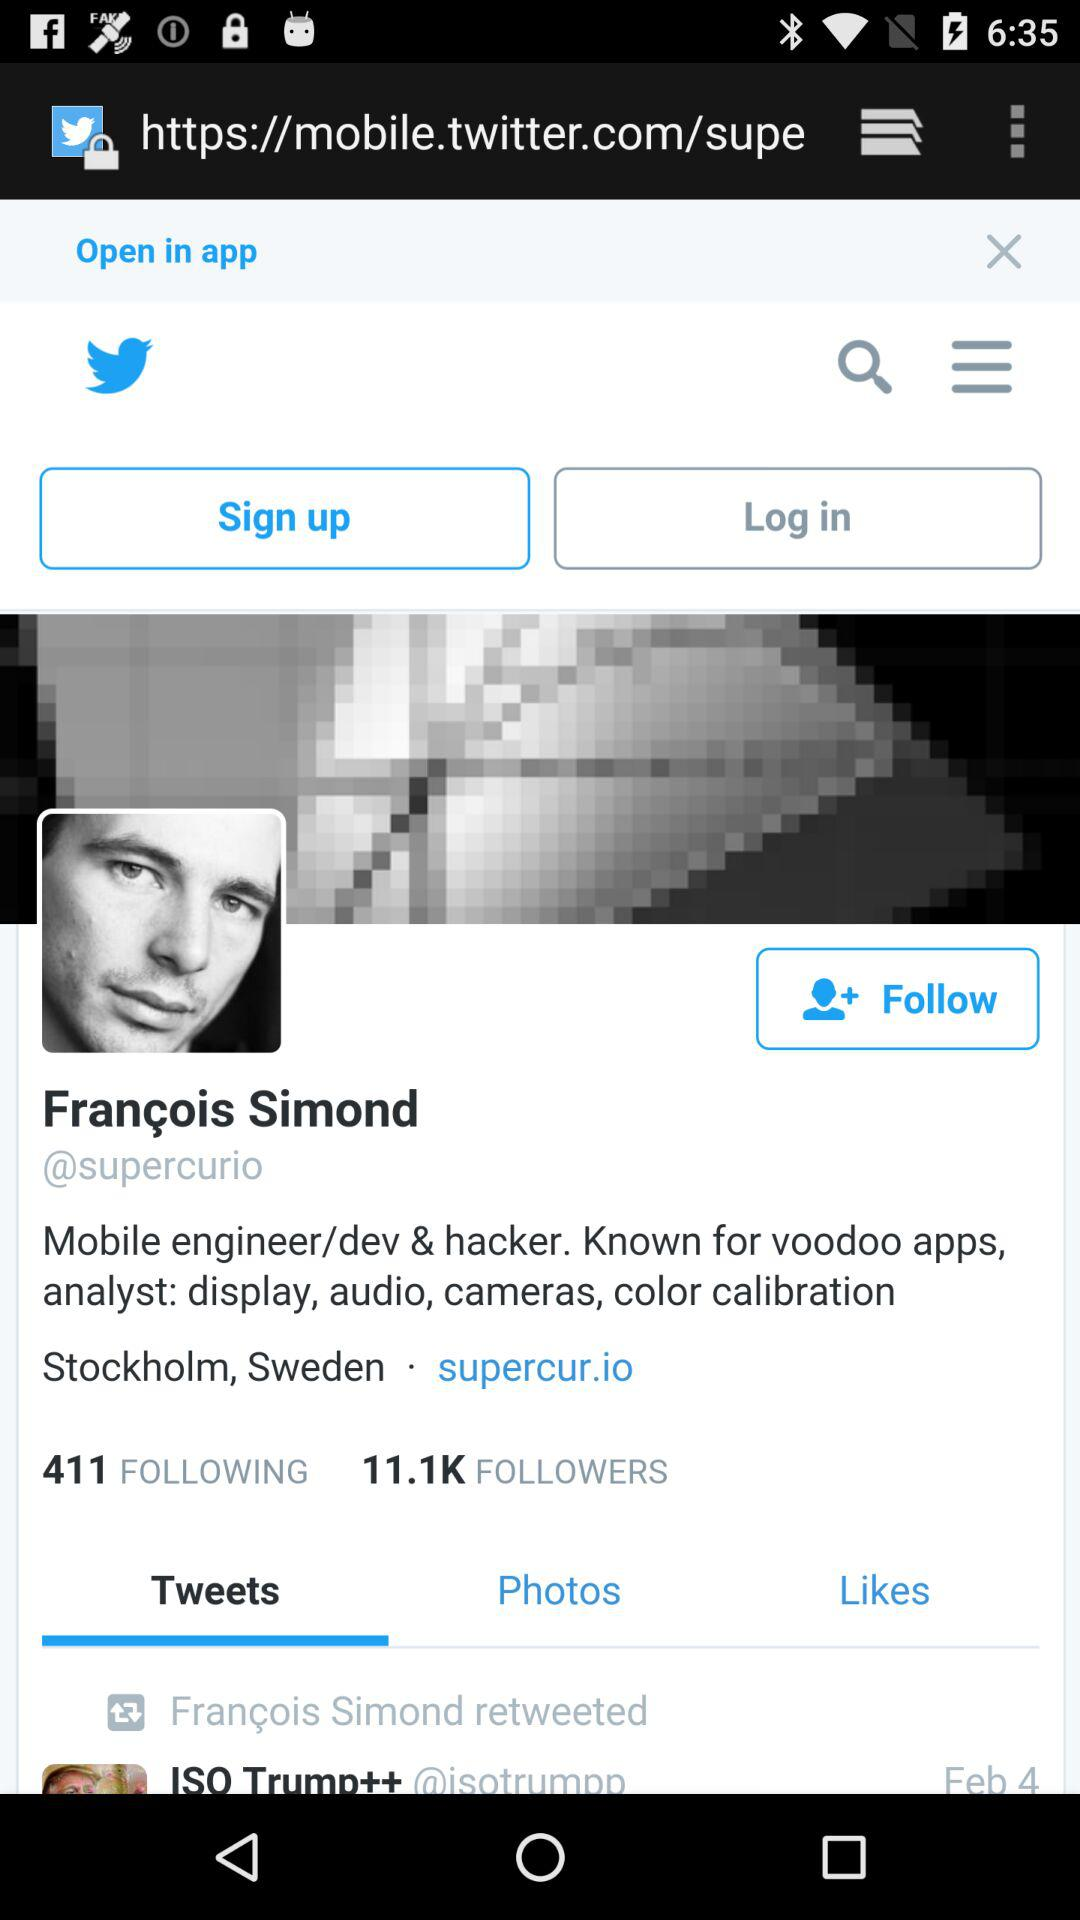What's the username? The username is François Simond. 